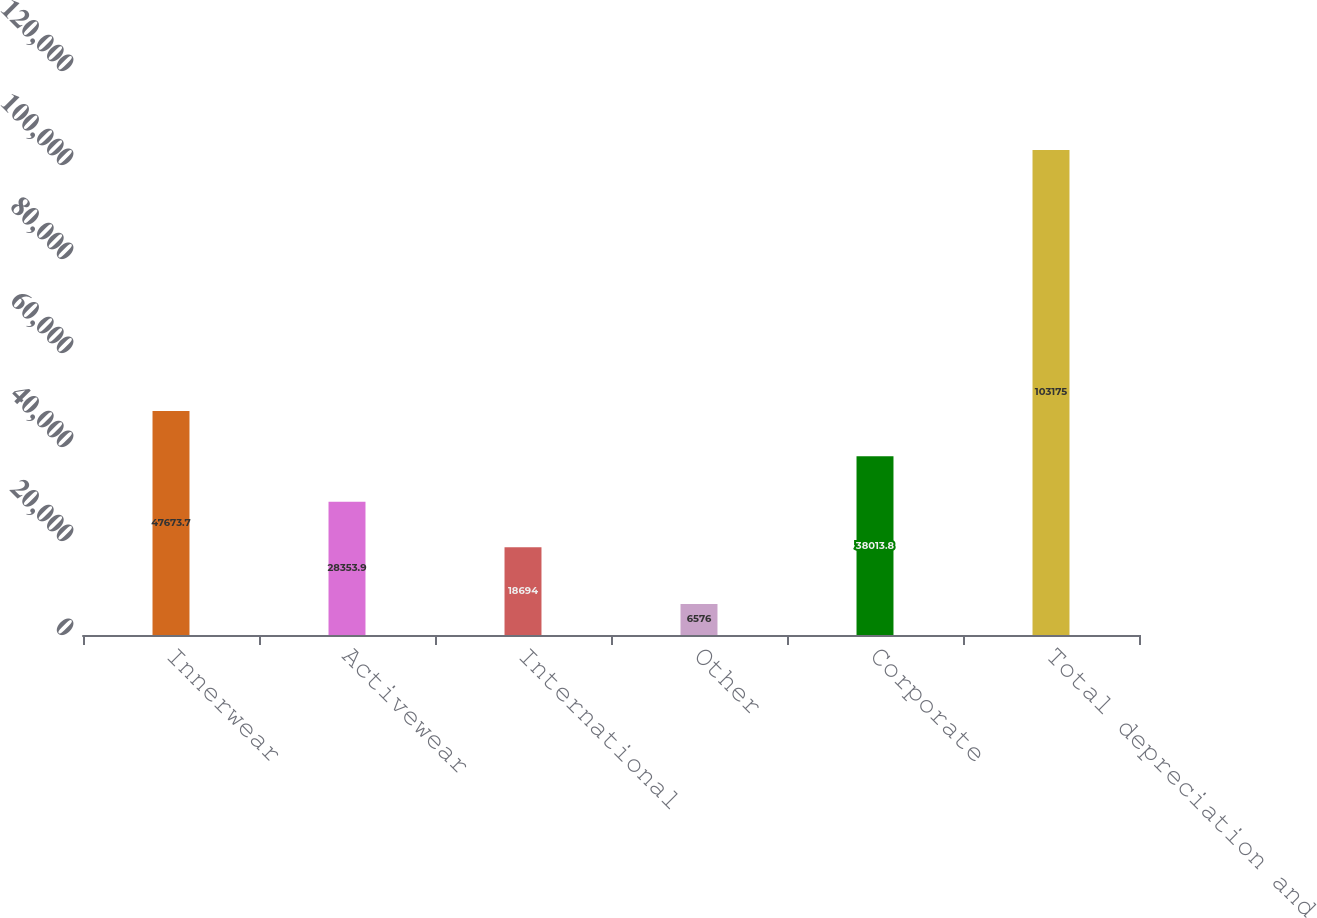<chart> <loc_0><loc_0><loc_500><loc_500><bar_chart><fcel>Innerwear<fcel>Activewear<fcel>International<fcel>Other<fcel>Corporate<fcel>Total depreciation and<nl><fcel>47673.7<fcel>28353.9<fcel>18694<fcel>6576<fcel>38013.8<fcel>103175<nl></chart> 